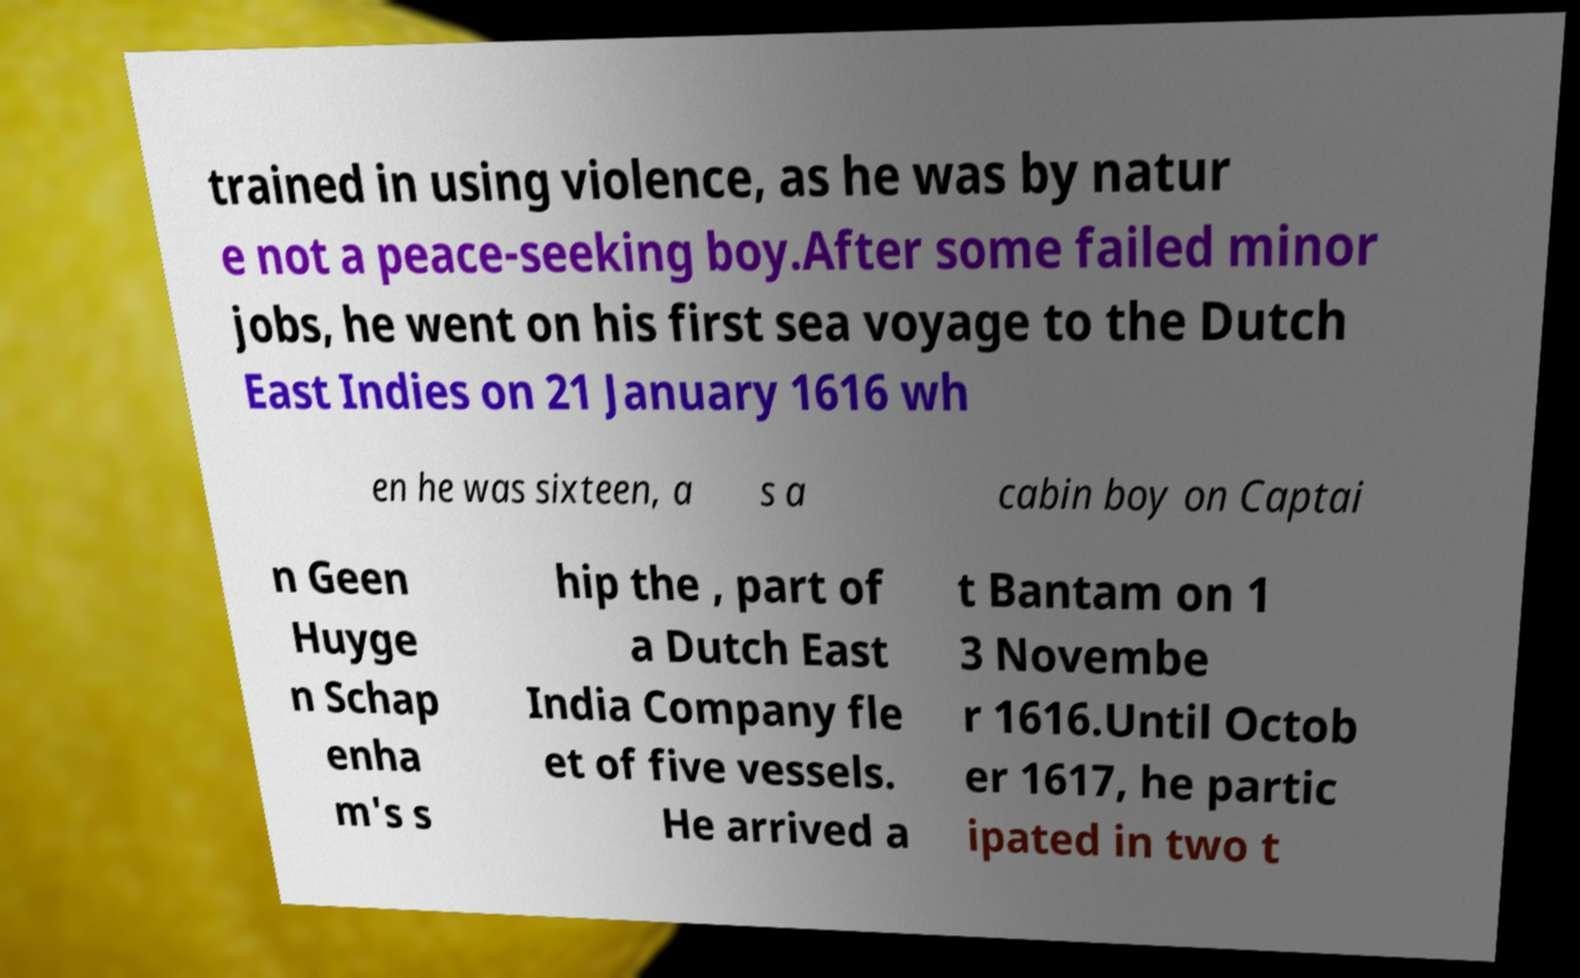Can you accurately transcribe the text from the provided image for me? trained in using violence, as he was by natur e not a peace-seeking boy.After some failed minor jobs, he went on his first sea voyage to the Dutch East Indies on 21 January 1616 wh en he was sixteen, a s a cabin boy on Captai n Geen Huyge n Schap enha m's s hip the , part of a Dutch East India Company fle et of five vessels. He arrived a t Bantam on 1 3 Novembe r 1616.Until Octob er 1617, he partic ipated in two t 